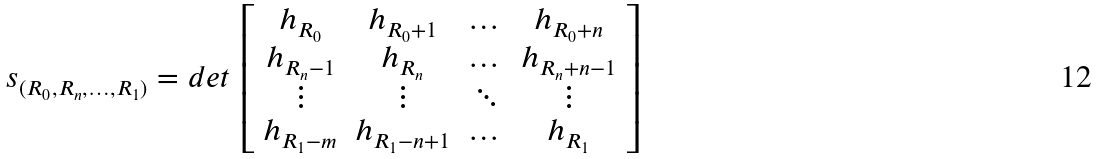Convert formula to latex. <formula><loc_0><loc_0><loc_500><loc_500>s _ { ( R _ { 0 } , R _ { n } , \dots , R _ { 1 } ) } = d e t \, \left [ \begin{array} { c c c c } h _ { R _ { 0 } } & h _ { R _ { 0 } + 1 } & \dots & h _ { R _ { 0 } + n } \\ h _ { R _ { n } - 1 } & h _ { R _ { n } } & \dots & h _ { R _ { n } + n - 1 } \\ \vdots & \vdots & \ddots & \vdots \\ h _ { R _ { 1 } - m } & h _ { R _ { 1 } - n + 1 } & \dots & h _ { R _ { 1 } } \end{array} \right ]</formula> 